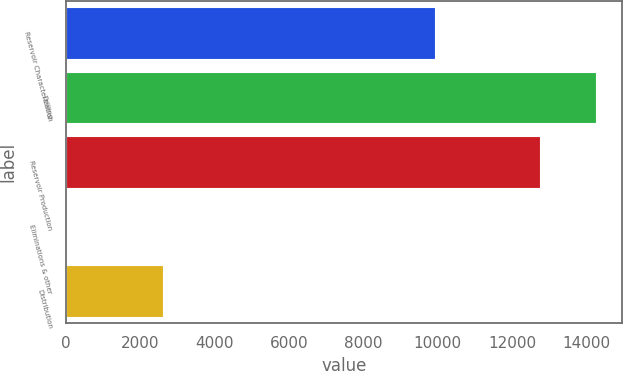Convert chart. <chart><loc_0><loc_0><loc_500><loc_500><bar_chart><fcel>Reservoir Characterization<fcel>Drilling<fcel>Reservoir Production<fcel>Eliminations & other<fcel>Distribution<nl><fcel>9929<fcel>14248<fcel>12748<fcel>34<fcel>2621<nl></chart> 